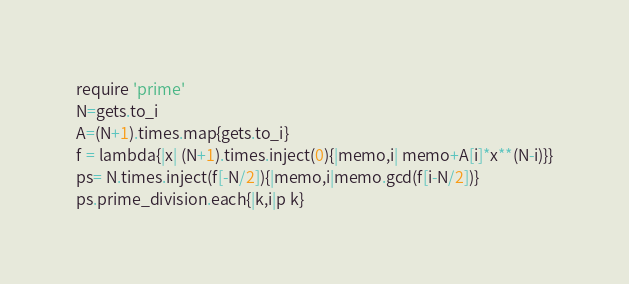Convert code to text. <code><loc_0><loc_0><loc_500><loc_500><_Ruby_>require 'prime'
N=gets.to_i
A=(N+1).times.map{gets.to_i}
f = lambda{|x| (N+1).times.inject(0){|memo,i| memo+A[i]*x**(N-i)}}
ps= N.times.inject(f[-N/2]){|memo,i|memo.gcd(f[i-N/2])}
ps.prime_division.each{|k,i|p k}</code> 